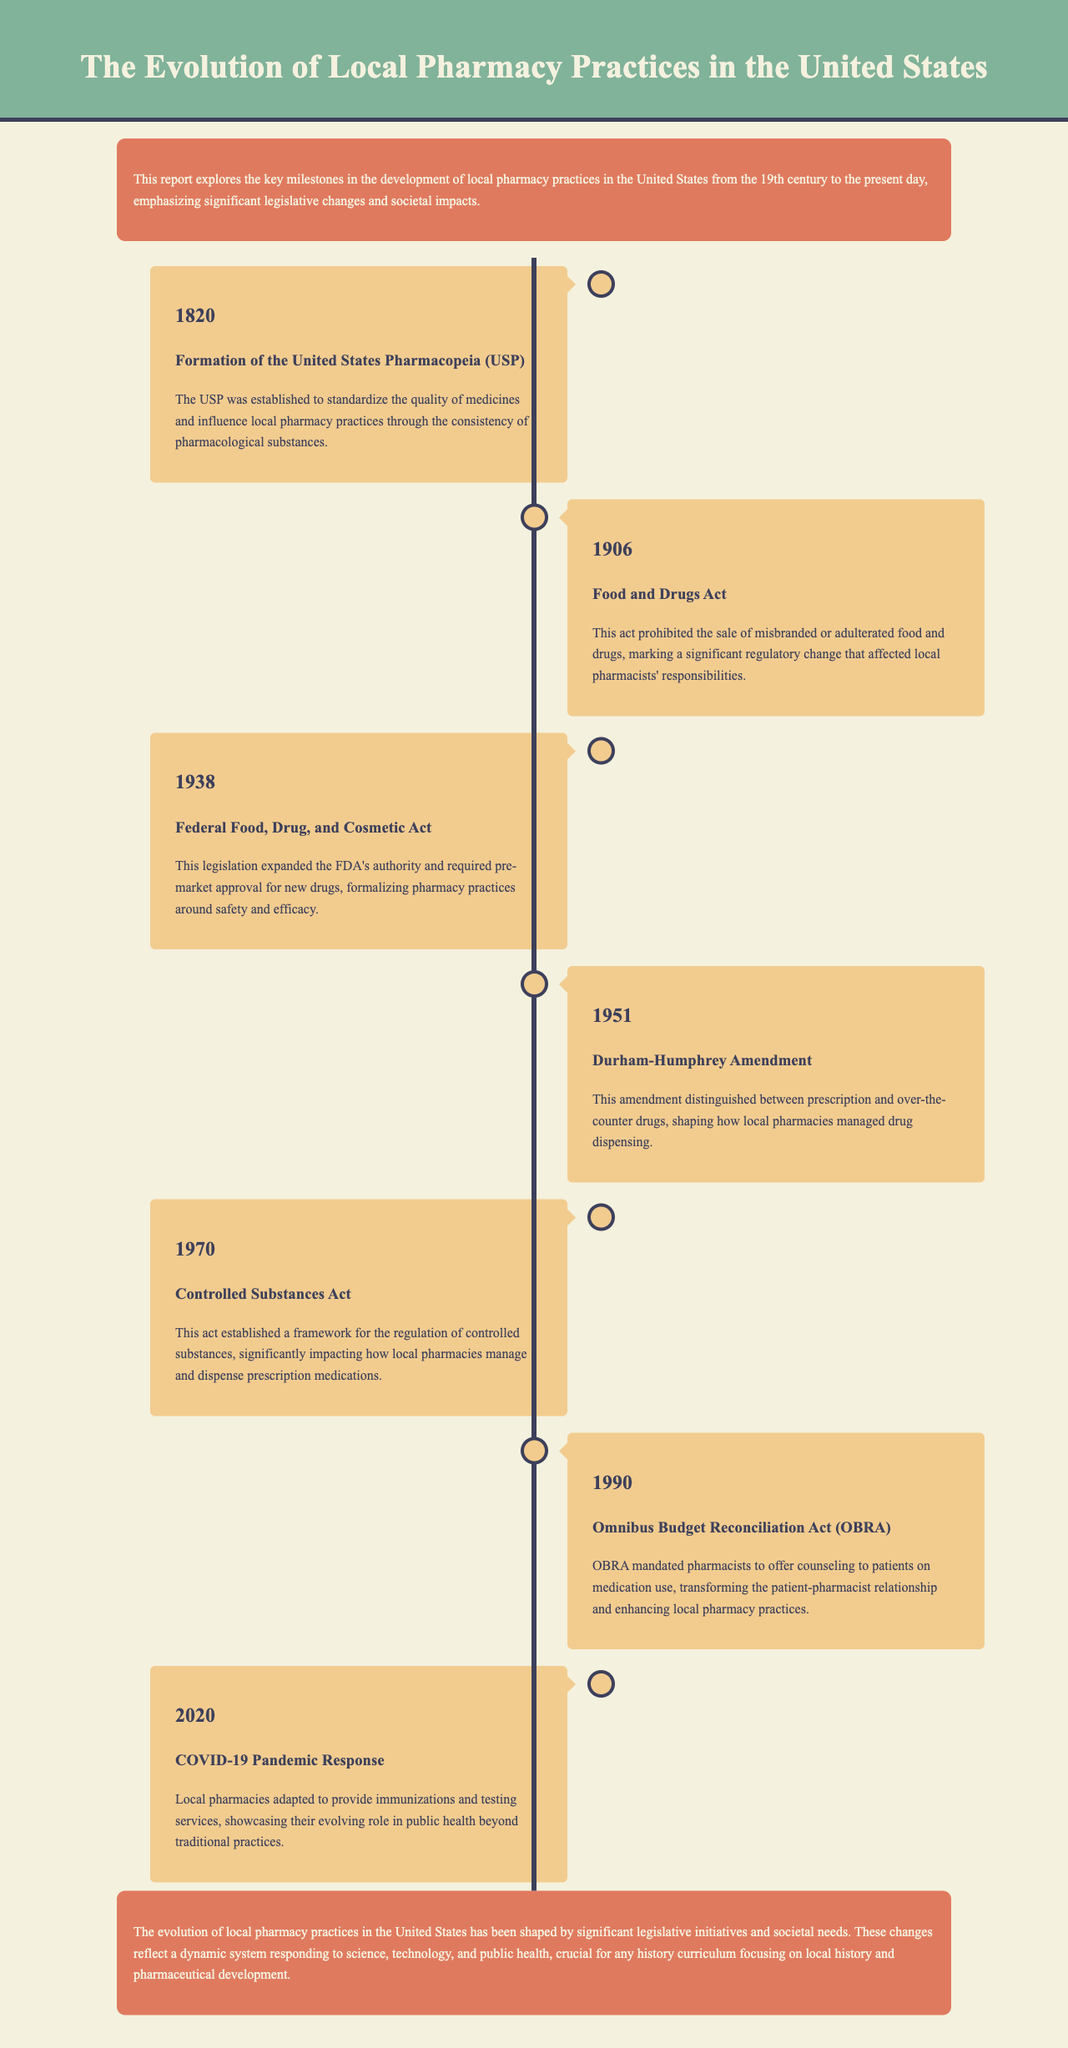What year was the United States Pharmacopeia established? The document states that the USP was established in 1820.
Answer: 1820 What is the significance of the Food and Drugs Act passed in 1906? The document explains that this act prohibited the sale of misbranded or adulterated food and drugs, marking a regulatory change affecting local pharmacists' responsibilities.
Answer: Prohibited misbranding What major legislation in 1938 expanded the FDA's authority? The document identifies the Federal Food, Drug, and Cosmetic Act as the legislation that expanded the FDA's authority.
Answer: Federal Food, Drug, and Cosmetic Act What change did the Durham-Humphrey Amendment of 1951 bring to local pharmacies? The document highlights that this amendment distinguished between prescription and over-the-counter drugs, shaping drug dispensing.
Answer: Prescription and over-the-counter distinction What framework was established by the Controlled Substances Act in 1970? The document states this act established a framework for the regulation of controlled substances.
Answer: Regulation of controlled substances In what year did the Omnibus Budget Reconciliation Act require pharmacists to offer patient counseling? The document indicates that the OBRA was enacted in 1990.
Answer: 1990 How did local pharmacies respond to the COVID-19 pandemic in 2020? According to the document, local pharmacies adapted to provide immunizations and testing services, showcasing their evolving role in public health.
Answer: Provided immunizations and testing services What aspect of pharmacy practices did the report emphasize in its conclusion? The document emphasizes that the evolution of local pharmacy practices reflects responses to science, technology, and public health.
Answer: Responses to science, technology, and public health 